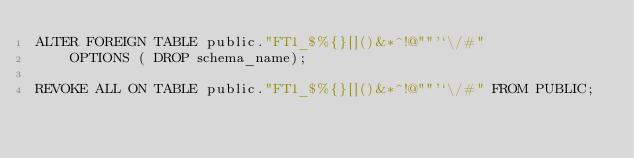Convert code to text. <code><loc_0><loc_0><loc_500><loc_500><_SQL_>ALTER FOREIGN TABLE public."FT1_$%{}[]()&*^!@""'`\/#"
    OPTIONS ( DROP schema_name);

REVOKE ALL ON TABLE public."FT1_$%{}[]()&*^!@""'`\/#" FROM PUBLIC;
</code> 